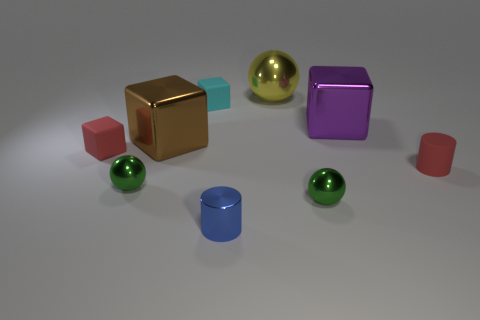What number of other things are there of the same size as the blue metallic cylinder?
Provide a succinct answer. 5. Are there the same number of cyan blocks on the left side of the tiny cyan rubber object and cubes to the left of the yellow metallic object?
Ensure brevity in your answer.  No. There is another tiny object that is the same shape as the tiny cyan thing; what is its color?
Make the answer very short. Red. Is there anything else that is the same shape as the cyan thing?
Your response must be concise. Yes. There is a metal ball left of the large brown thing; is its color the same as the small metallic cylinder?
Offer a terse response. No. What is the size of the other thing that is the same shape as the tiny blue thing?
Your answer should be compact. Small. What number of green spheres are made of the same material as the large purple block?
Offer a very short reply. 2. There is a small green metal sphere that is on the right side of the large thing that is on the left side of the cyan rubber block; are there any small red matte cylinders that are in front of it?
Make the answer very short. No. The big yellow thing has what shape?
Your answer should be compact. Sphere. Does the small red object to the left of the cyan block have the same material as the red thing on the right side of the big purple metal object?
Provide a succinct answer. Yes. 